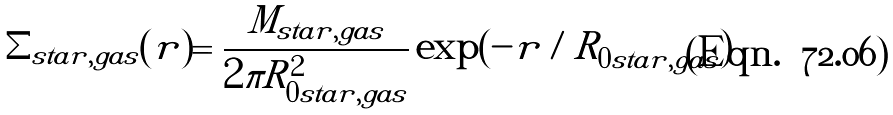<formula> <loc_0><loc_0><loc_500><loc_500>\Sigma _ { s t a r , g a s } ( r ) = \frac { M _ { s t a r , g a s } } { 2 \pi R _ { 0 s t a r , g a s } ^ { 2 } } \exp ( - r / R _ { 0 s t a r , g a s } )</formula> 